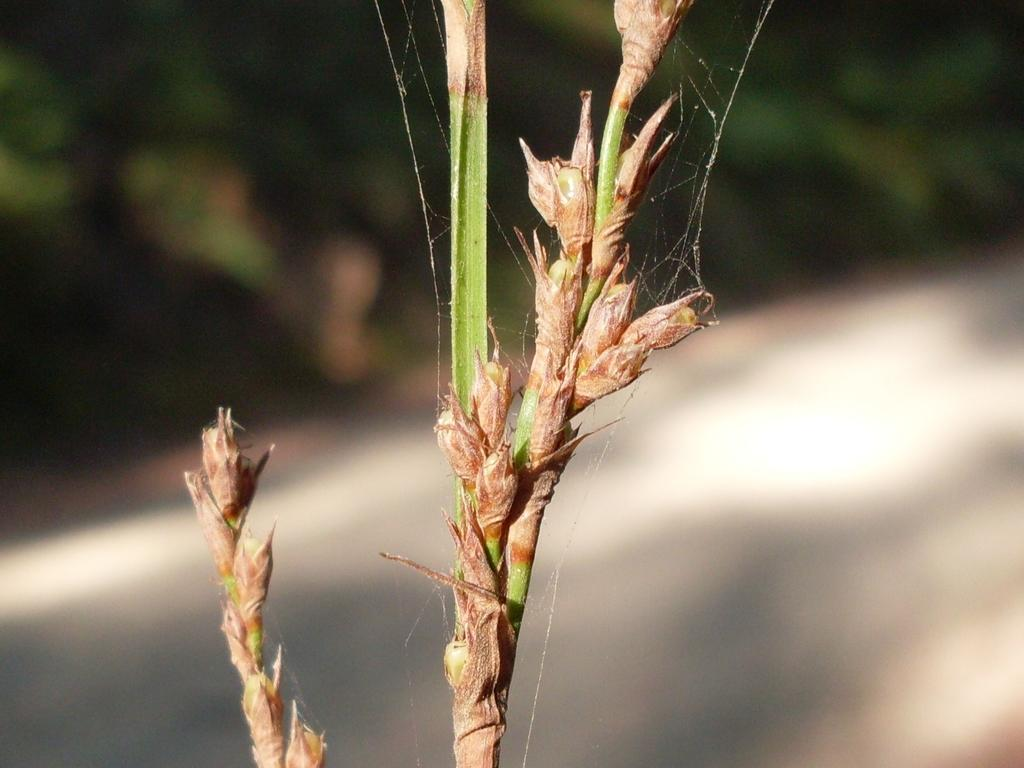What is the main subject in the image? There is a plant in the image. Can you describe the background of the image? The background of the image is blurred. What type of parent can be seen interacting with the plant in the image? There is no parent present in the image; it only features a plant and a blurred background. Is there a bridge visible in the image? No, there is no bridge present in the image. 